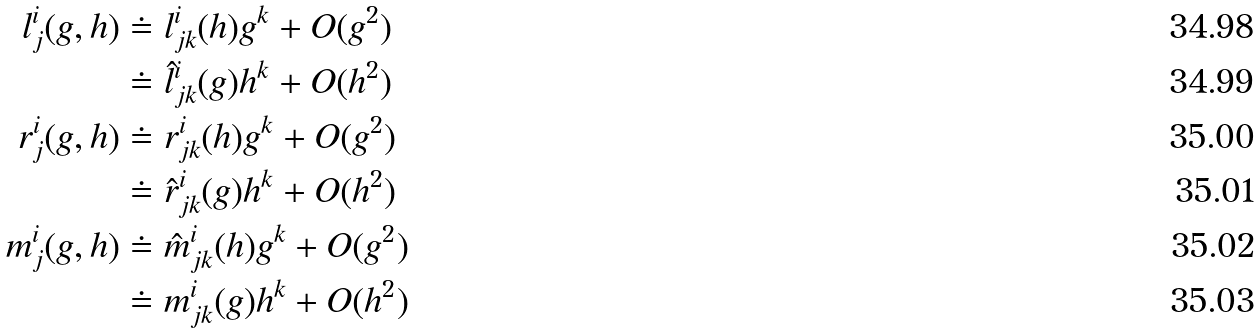<formula> <loc_0><loc_0><loc_500><loc_500>l ^ { i } _ { j } ( g , h ) & \doteq l ^ { i } _ { j k } ( h ) g ^ { k } + O ( g ^ { 2 } ) \\ & \doteq \hat { l } ^ { i } _ { j k } ( g ) h ^ { k } + O ( h ^ { 2 } ) \\ r ^ { i } _ { j } ( g , h ) & \doteq r ^ { i } _ { j k } ( h ) g ^ { k } + O ( g ^ { 2 } ) \\ & \doteq \hat { r } ^ { i } _ { j k } ( g ) h ^ { k } + O ( h ^ { 2 } ) \\ m ^ { i } _ { j } ( g , h ) & \doteq \hat { m } ^ { i } _ { j k } ( h ) g ^ { k } + O ( g ^ { 2 } ) \\ & \doteq m ^ { i } _ { j k } ( g ) h ^ { k } + O ( h ^ { 2 } )</formula> 